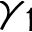<formula> <loc_0><loc_0><loc_500><loc_500>\gamma _ { 1 }</formula> 